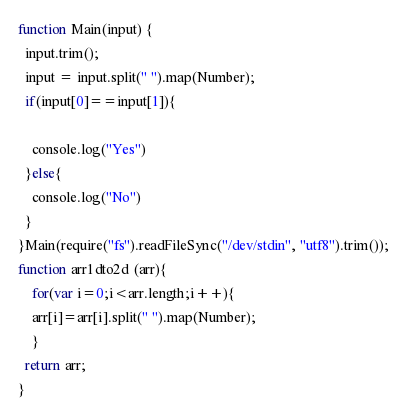Convert code to text. <code><loc_0><loc_0><loc_500><loc_500><_JavaScript_>function Main(input) {
  input.trim();
  input = input.split(" ").map(Number);
  if(input[0]==input[1]){

    console.log("Yes")
  }else{
    console.log("No")
  }
}Main(require("fs").readFileSync("/dev/stdin", "utf8").trim());
function arr1dto2d (arr){
	for(var i=0;i<arr.length;i++){
    arr[i]=arr[i].split(" ").map(Number);
    }
  return arr;
}
</code> 